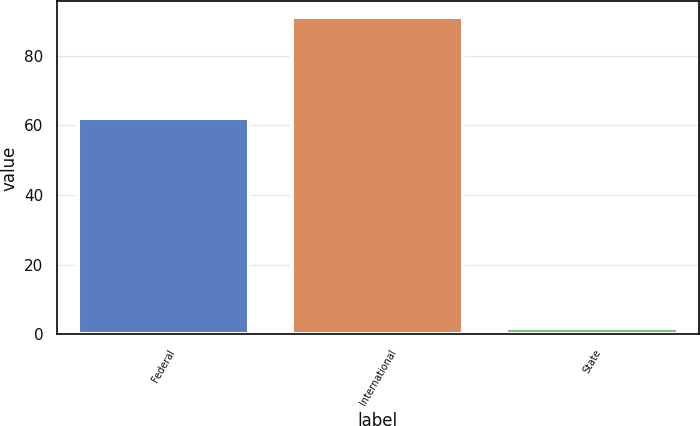Convert chart. <chart><loc_0><loc_0><loc_500><loc_500><bar_chart><fcel>Federal<fcel>International<fcel>State<nl><fcel>62<fcel>91<fcel>2<nl></chart> 